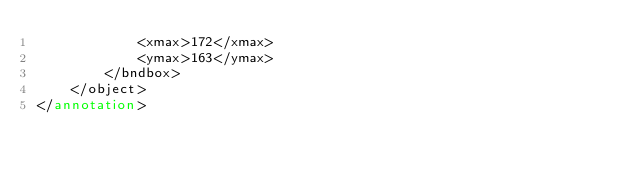Convert code to text. <code><loc_0><loc_0><loc_500><loc_500><_XML_>			<xmax>172</xmax>
			<ymax>163</ymax>
		</bndbox>
	</object>
</annotation>
</code> 